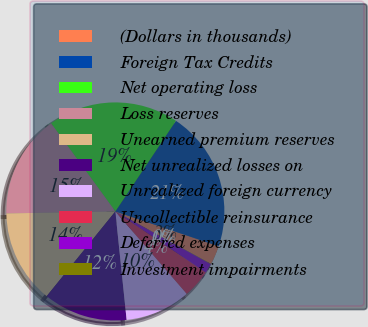Convert chart to OTSL. <chart><loc_0><loc_0><loc_500><loc_500><pie_chart><fcel>(Dollars in thousands)<fcel>Foreign Tax Credits<fcel>Net operating loss<fcel>Loss reserves<fcel>Unearned premium reserves<fcel>Net unrealized losses on<fcel>Unrealized foreign currency<fcel>Uncollectible reinsurance<fcel>Deferred expenses<fcel>Investment impairments<nl><fcel>2.81%<fcel>20.79%<fcel>19.41%<fcel>15.26%<fcel>13.87%<fcel>12.49%<fcel>9.72%<fcel>4.19%<fcel>1.42%<fcel>0.04%<nl></chart> 